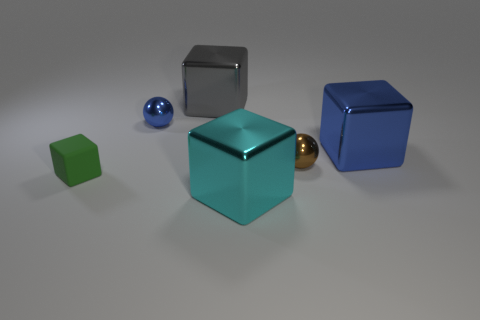Subtract 1 blocks. How many blocks are left? 3 Add 2 large purple metallic spheres. How many objects exist? 8 Subtract all spheres. How many objects are left? 4 Add 4 tiny metal spheres. How many tiny metal spheres exist? 6 Subtract 0 purple blocks. How many objects are left? 6 Subtract all small brown metallic objects. Subtract all small blue objects. How many objects are left? 4 Add 2 green blocks. How many green blocks are left? 3 